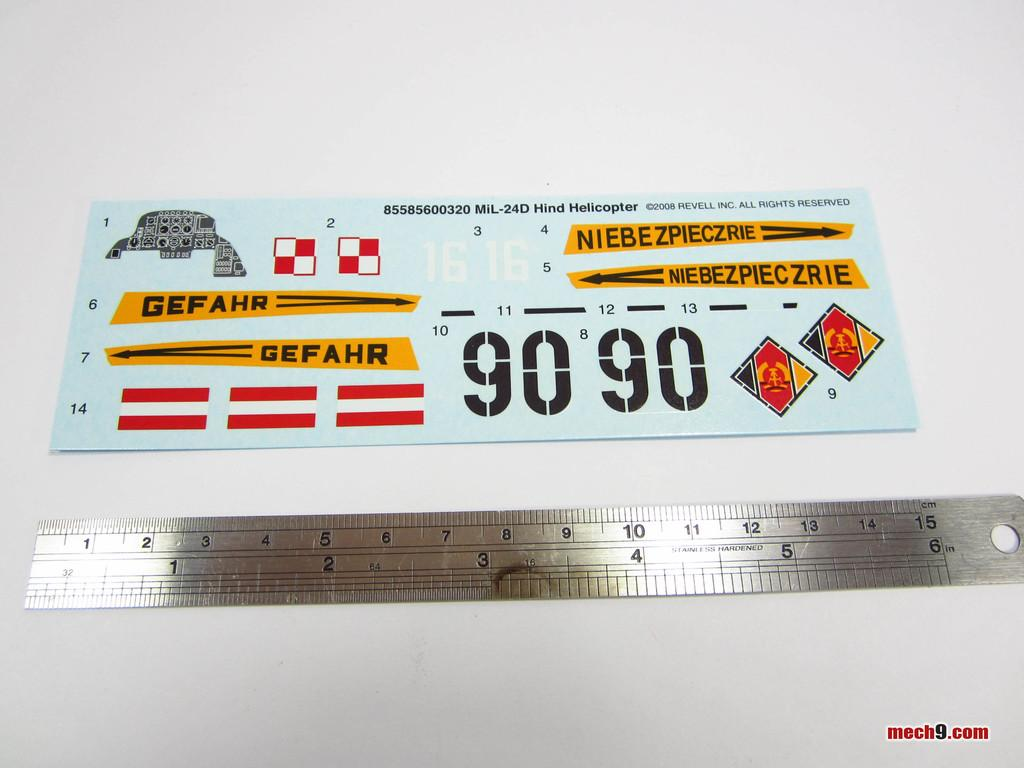Provide a one-sentence caption for the provided image. A metal ruler is lying next to a piece of paper with the number 9090 on it. 